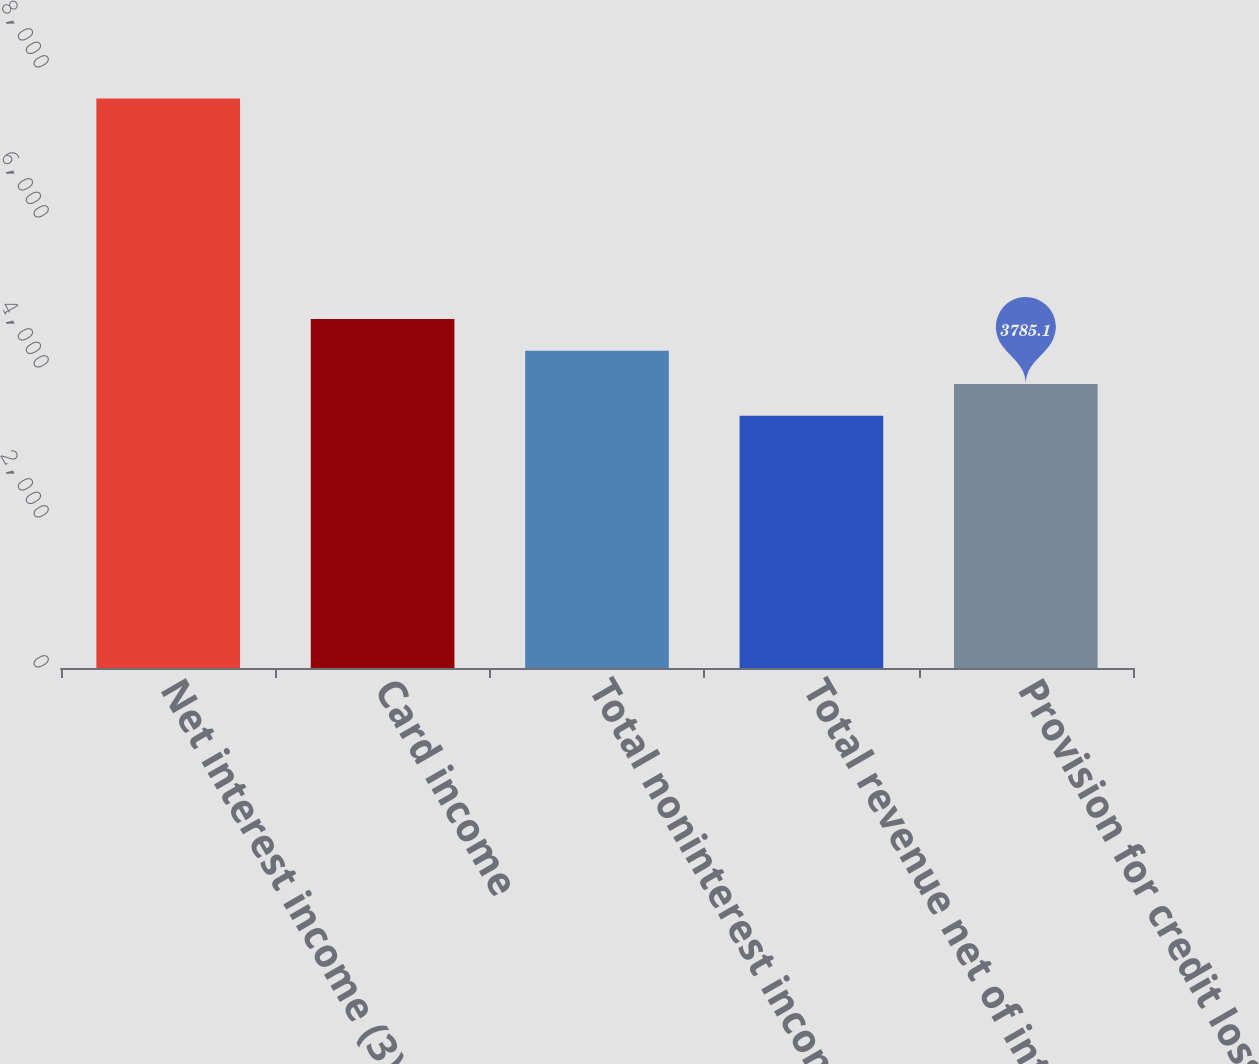Convert chart. <chart><loc_0><loc_0><loc_500><loc_500><bar_chart><fcel>Net interest income (3)<fcel>Card income<fcel>Total noninterest income<fcel>Total revenue net of interest<fcel>Provision for credit losses<nl><fcel>7593<fcel>4654.1<fcel>4231<fcel>3362<fcel>3785.1<nl></chart> 